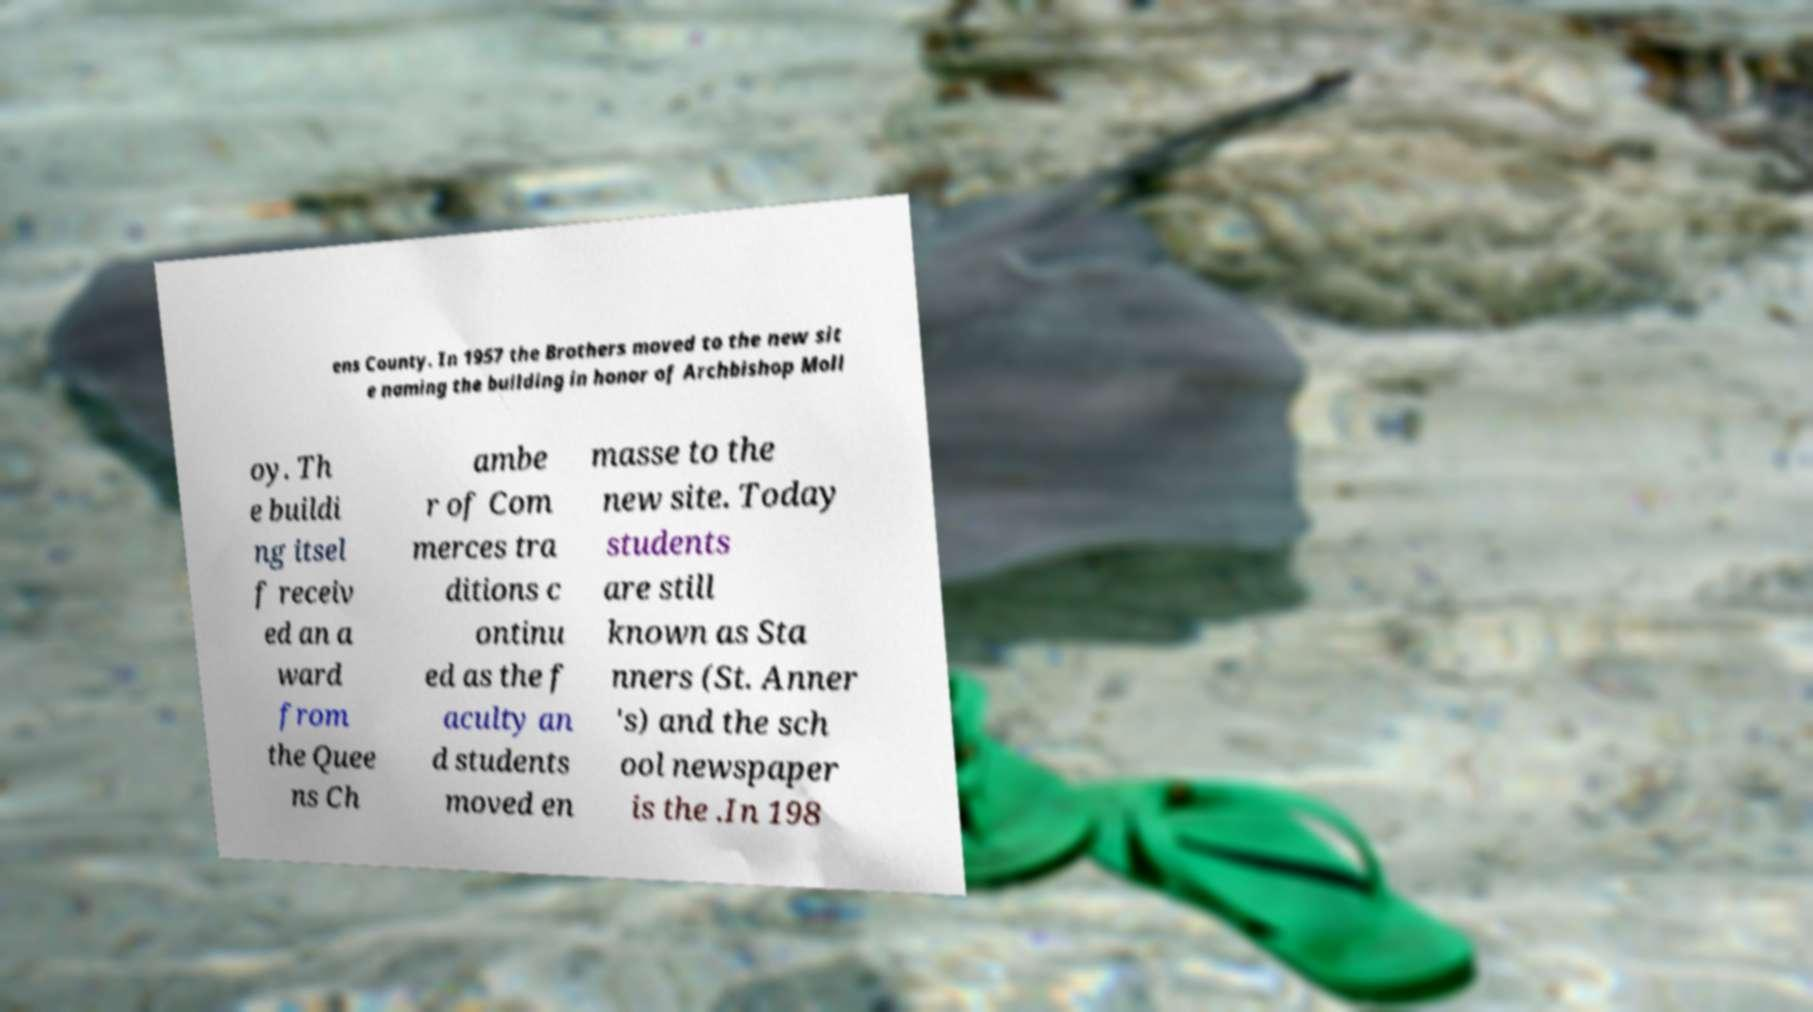There's text embedded in this image that I need extracted. Can you transcribe it verbatim? ens County. In 1957 the Brothers moved to the new sit e naming the building in honor of Archbishop Moll oy. Th e buildi ng itsel f receiv ed an a ward from the Quee ns Ch ambe r of Com merces tra ditions c ontinu ed as the f aculty an d students moved en masse to the new site. Today students are still known as Sta nners (St. Anner 's) and the sch ool newspaper is the .In 198 